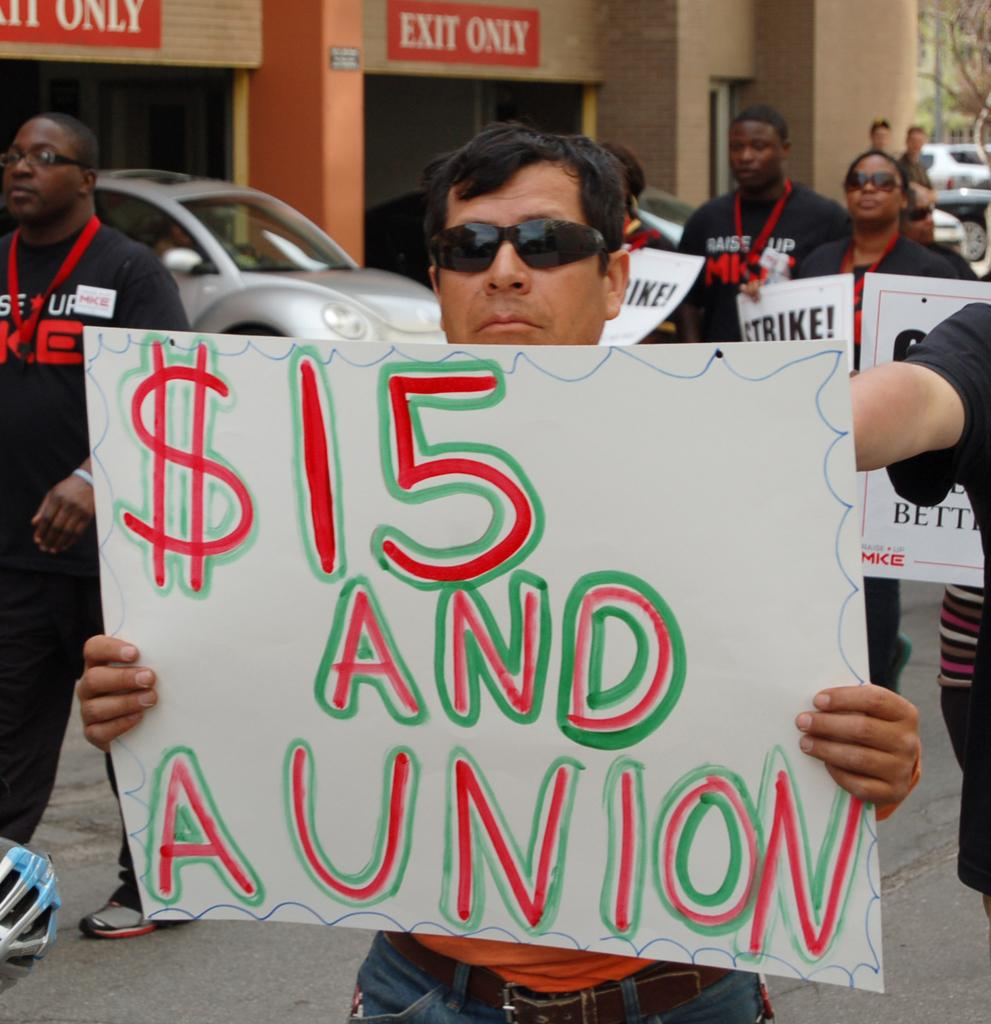Who is present in the image? There is a man in the image. What is the man holding in his hand? The man is holding a placard in his hand. What else can be seen in the image besides the man? There is a vehicle in the image. Where is the vehicle located in relation to the building? The vehicle is under a building. What type of flag is flying above the arch in the image? There is no flag or arch present in the image. What kind of business is being conducted in the image? The image does not depict any business activity; it only shows a man holding a placard and a vehicle under a building. 